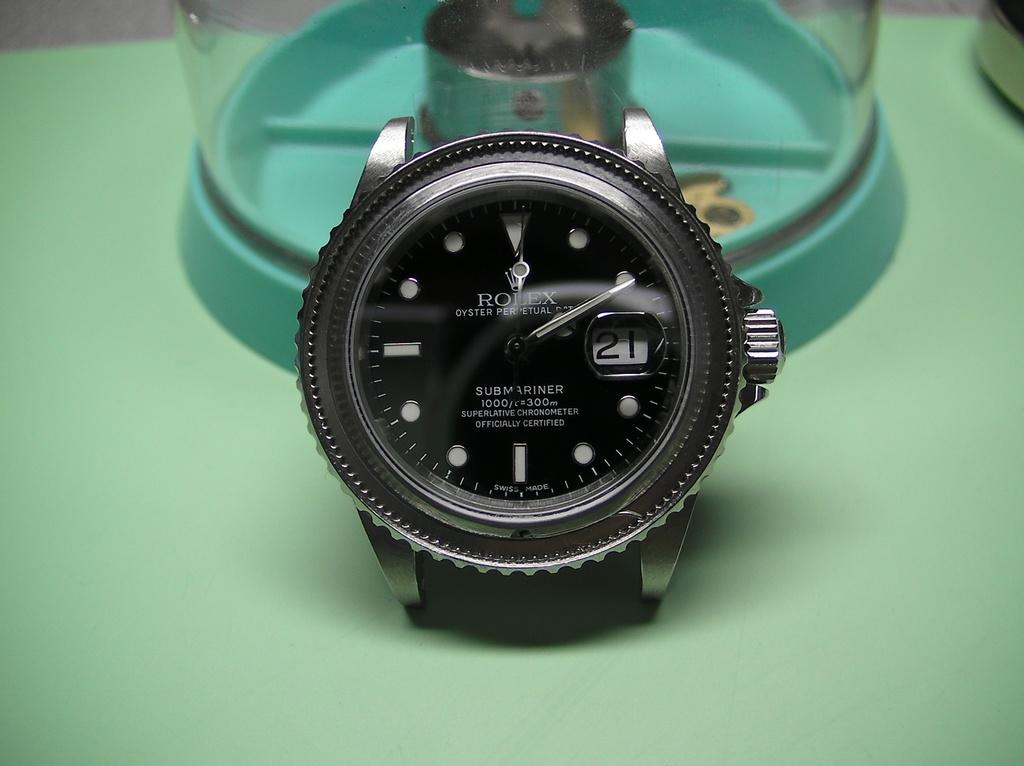Provide a one-sentence caption for the provided image. Rolex Submariner is displayed on this expensive looking watch. 